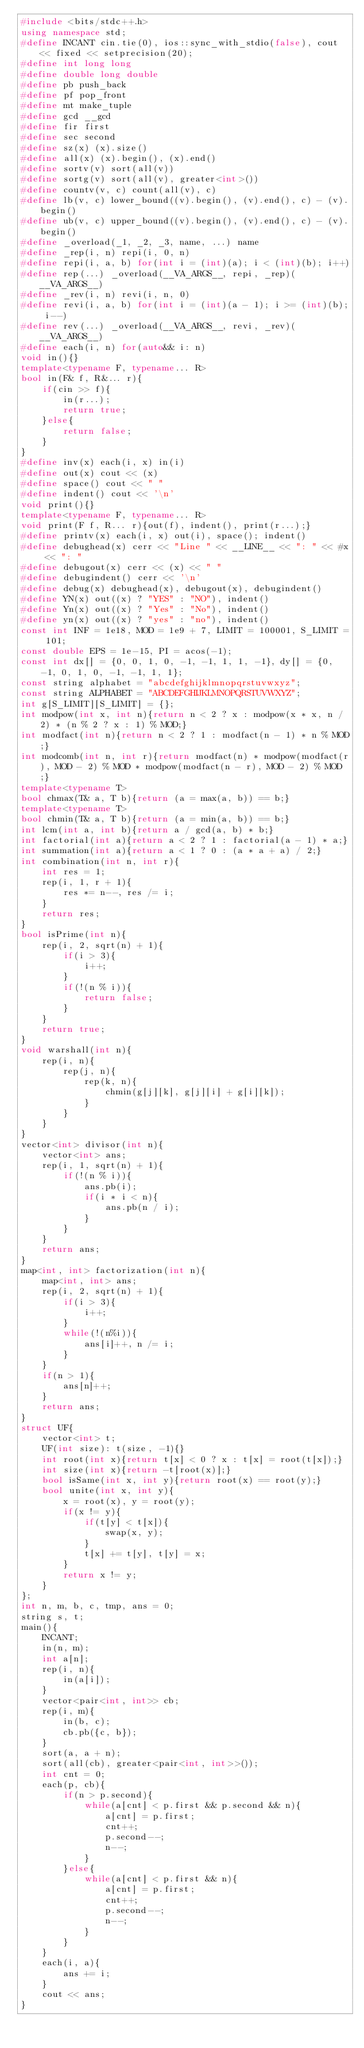<code> <loc_0><loc_0><loc_500><loc_500><_C++_>#include <bits/stdc++.h>
using namespace std;
#define INCANT cin.tie(0), ios::sync_with_stdio(false), cout << fixed << setprecision(20);
#define int long long
#define double long double
#define pb push_back
#define pf pop_front
#define mt make_tuple
#define gcd __gcd
#define fir first
#define sec second
#define sz(x) (x).size()
#define all(x) (x).begin(), (x).end()
#define sortv(v) sort(all(v))
#define sortg(v) sort(all(v), greater<int>())
#define countv(v, c) count(all(v), c)
#define lb(v, c) lower_bound((v).begin(), (v).end(), c) - (v).begin()
#define ub(v, c) upper_bound((v).begin(), (v).end(), c) - (v).begin()
#define _overload(_1, _2, _3, name, ...) name
#define _rep(i, n) repi(i, 0, n)
#define repi(i, a, b) for(int i = (int)(a); i < (int)(b); i++)
#define rep(...) _overload(__VA_ARGS__, repi, _rep)(__VA_ARGS__)
#define _rev(i, n) revi(i, n, 0)
#define revi(i, a, b) for(int i = (int)(a - 1); i >= (int)(b); i--)
#define rev(...) _overload(__VA_ARGS__, revi, _rev)(__VA_ARGS__)
#define each(i, n) for(auto&& i: n)
void in(){}
template<typename F, typename... R>
bool in(F& f, R&... r){
    if(cin >> f){
        in(r...);
        return true;
    }else{
        return false;
    }
}
#define inv(x) each(i, x) in(i)
#define out(x) cout << (x)
#define space() cout << " "
#define indent() cout << '\n'
void print(){}
template<typename F, typename... R>
void print(F f, R... r){out(f), indent(), print(r...);}
#define printv(x) each(i, x) out(i), space(); indent()
#define debughead(x) cerr << "Line " << __LINE__ << ": " << #x << ": "
#define debugout(x) cerr << (x) << " "
#define debugindent() cerr << '\n'
#define debug(x) debughead(x), debugout(x), debugindent()
#define YN(x) out((x) ? "YES" : "NO"), indent()
#define Yn(x) out((x) ? "Yes" : "No"), indent()
#define yn(x) out((x) ? "yes" : "no"), indent()
const int INF = 1e18, MOD = 1e9 + 7, LIMIT = 100001, S_LIMIT = 101;
const double EPS = 1e-15, PI = acos(-1);
const int dx[] = {0, 0, 1, 0, -1, -1, 1, 1, -1}, dy[] = {0, -1, 0, 1, 0, -1, -1, 1, 1};
const string alphabet = "abcdefghijklmnopqrstuvwxyz";
const string ALPHABET = "ABCDEFGHIJKLMNOPQRSTUVWXYZ";
int g[S_LIMIT][S_LIMIT] = {};
int modpow(int x, int n){return n < 2 ? x : modpow(x * x, n / 2) * (n % 2 ? x : 1) % MOD;}
int modfact(int n){return n < 2 ? 1 : modfact(n - 1) * n % MOD;}
int modcomb(int n, int r){return modfact(n) * modpow(modfact(r), MOD - 2) % MOD * modpow(modfact(n - r), MOD - 2) % MOD;}
template<typename T>
bool chmax(T& a, T b){return (a = max(a, b)) == b;}
template<typename T>
bool chmin(T& a, T b){return (a = min(a, b)) == b;}
int lcm(int a, int b){return a / gcd(a, b) * b;}
int factorial(int a){return a < 2 ? 1 : factorial(a - 1) * a;}
int summation(int a){return a < 1 ? 0 : (a * a + a) / 2;}
int combination(int n, int r){
    int res = 1;
    rep(i, 1, r + 1){
        res *= n--, res /= i;
    }
    return res;
}
bool isPrime(int n){
    rep(i, 2, sqrt(n) + 1){
        if(i > 3){
            i++;
        }
        if(!(n % i)){
            return false;
        }
    }
    return true;
}
void warshall(int n){
    rep(i, n){
        rep(j, n){
            rep(k, n){
                chmin(g[j][k], g[j][i] + g[i][k]);
            }
        }
    }
}
vector<int> divisor(int n){
    vector<int> ans;
    rep(i, 1, sqrt(n) + 1){
        if(!(n % i)){
            ans.pb(i);
            if(i * i < n){
                ans.pb(n / i);
            }
        }
    }
    return ans;
}
map<int, int> factorization(int n){
    map<int, int> ans;
    rep(i, 2, sqrt(n) + 1){
        if(i > 3){
            i++;
        }
        while(!(n%i)){
            ans[i]++, n /= i;
        }
    }
    if(n > 1){
        ans[n]++;
    }
    return ans;
}
struct UF{
    vector<int> t;
    UF(int size): t(size, -1){}
    int root(int x){return t[x] < 0 ? x : t[x] = root(t[x]);}
    int size(int x){return -t[root(x)];}
    bool isSame(int x, int y){return root(x) == root(y);}
    bool unite(int x, int y){
        x = root(x), y = root(y);
        if(x != y){
            if(t[y] < t[x]){
                swap(x, y);
            }
            t[x] += t[y], t[y] = x;
        }
        return x != y;
    }
};
int n, m, b, c, tmp, ans = 0;
string s, t;
main(){
    INCANT;
    in(n, m);
    int a[n];
    rep(i, n){
        in(a[i]);
    }
    vector<pair<int, int>> cb;
    rep(i, m){
        in(b, c);
        cb.pb({c, b});
    }
    sort(a, a + n);
    sort(all(cb), greater<pair<int, int>>());
    int cnt = 0;
    each(p, cb){
        if(n > p.second){
            while(a[cnt] < p.first && p.second && n){
                a[cnt] = p.first;
                cnt++;
                p.second--;
                n--;
            }
        }else{
            while(a[cnt] < p.first && n){
                a[cnt] = p.first;
                cnt++;
                p.second--;
                n--;
            }
        }
    }
    each(i, a){
        ans += i;
    }
    cout << ans;
}
</code> 